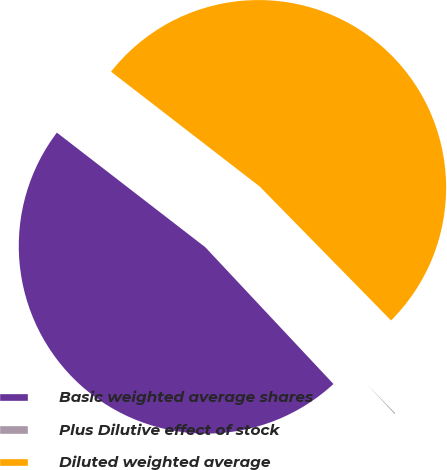<chart> <loc_0><loc_0><loc_500><loc_500><pie_chart><fcel>Basic weighted average shares<fcel>Plus Dilutive effect of stock<fcel>Diluted weighted average<nl><fcel>47.45%<fcel>0.36%<fcel>52.19%<nl></chart> 